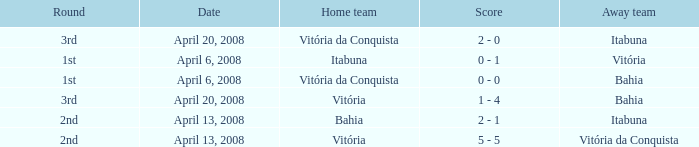What is the name of the home team on April 13, 2008 when Itabuna was the away team? Bahia. 